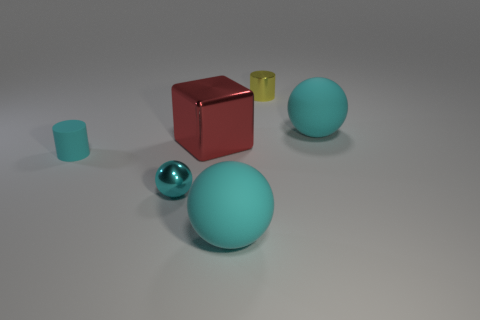Add 1 large red objects. How many objects exist? 7 Subtract all blocks. How many objects are left? 5 Add 5 large red shiny objects. How many large red shiny objects exist? 6 Subtract 0 yellow cubes. How many objects are left? 6 Subtract all red metal blocks. Subtract all red metal objects. How many objects are left? 4 Add 1 small cyan spheres. How many small cyan spheres are left? 2 